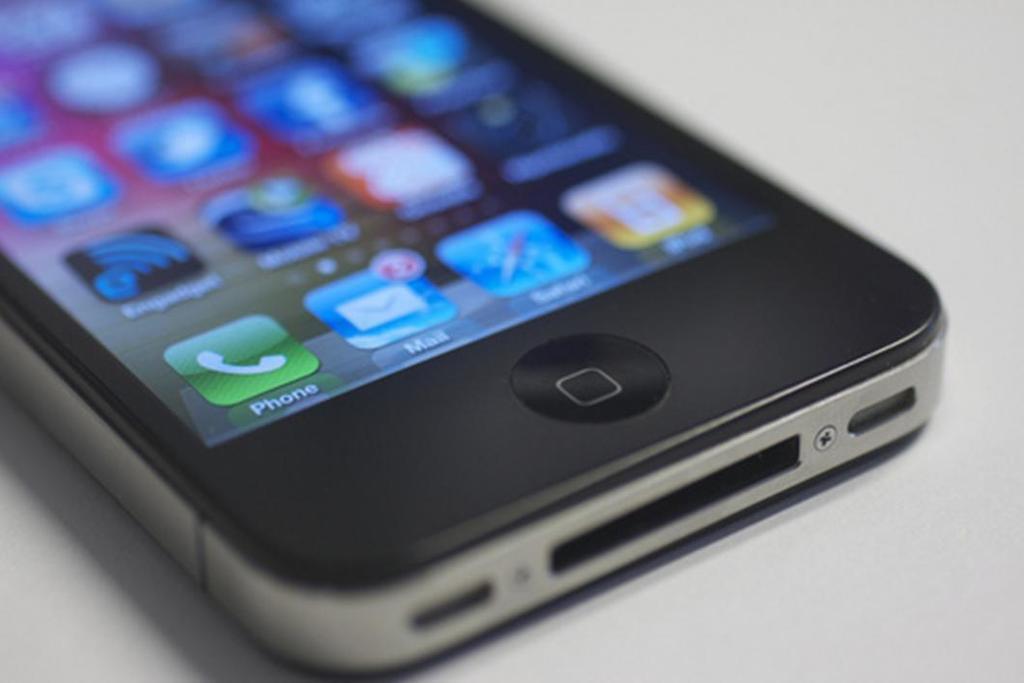Please provide a concise description of this image. In this image there is a zoom in picture of a mobile as we can see there are some icons on the display of this mobile. 